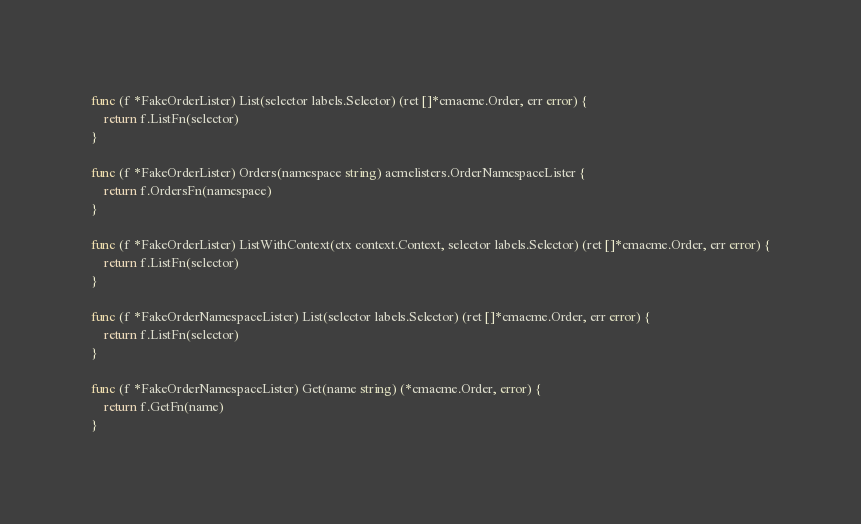<code> <loc_0><loc_0><loc_500><loc_500><_Go_>func (f *FakeOrderLister) List(selector labels.Selector) (ret []*cmacme.Order, err error) {
	return f.ListFn(selector)
}

func (f *FakeOrderLister) Orders(namespace string) acmelisters.OrderNamespaceLister {
	return f.OrdersFn(namespace)
}

func (f *FakeOrderLister) ListWithContext(ctx context.Context, selector labels.Selector) (ret []*cmacme.Order, err error) {
	return f.ListFn(selector)
}

func (f *FakeOrderNamespaceLister) List(selector labels.Selector) (ret []*cmacme.Order, err error) {
	return f.ListFn(selector)
}

func (f *FakeOrderNamespaceLister) Get(name string) (*cmacme.Order, error) {
	return f.GetFn(name)
}
</code> 